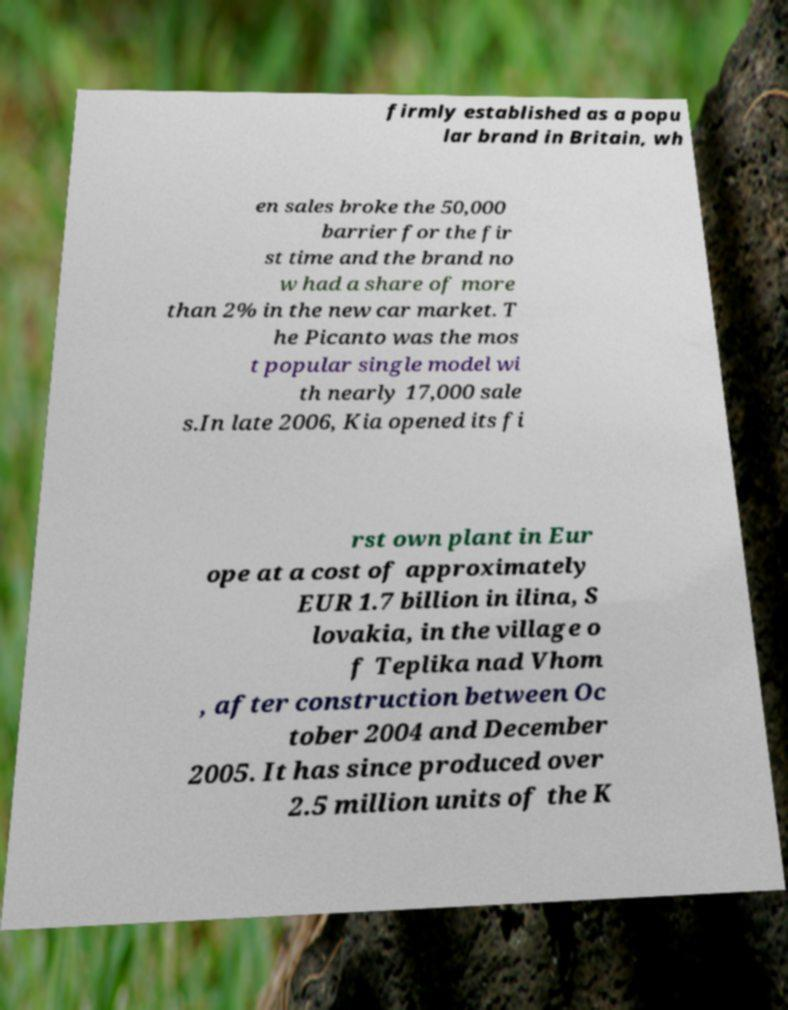Please identify and transcribe the text found in this image. firmly established as a popu lar brand in Britain, wh en sales broke the 50,000 barrier for the fir st time and the brand no w had a share of more than 2% in the new car market. T he Picanto was the mos t popular single model wi th nearly 17,000 sale s.In late 2006, Kia opened its fi rst own plant in Eur ope at a cost of approximately EUR 1.7 billion in ilina, S lovakia, in the village o f Teplika nad Vhom , after construction between Oc tober 2004 and December 2005. It has since produced over 2.5 million units of the K 